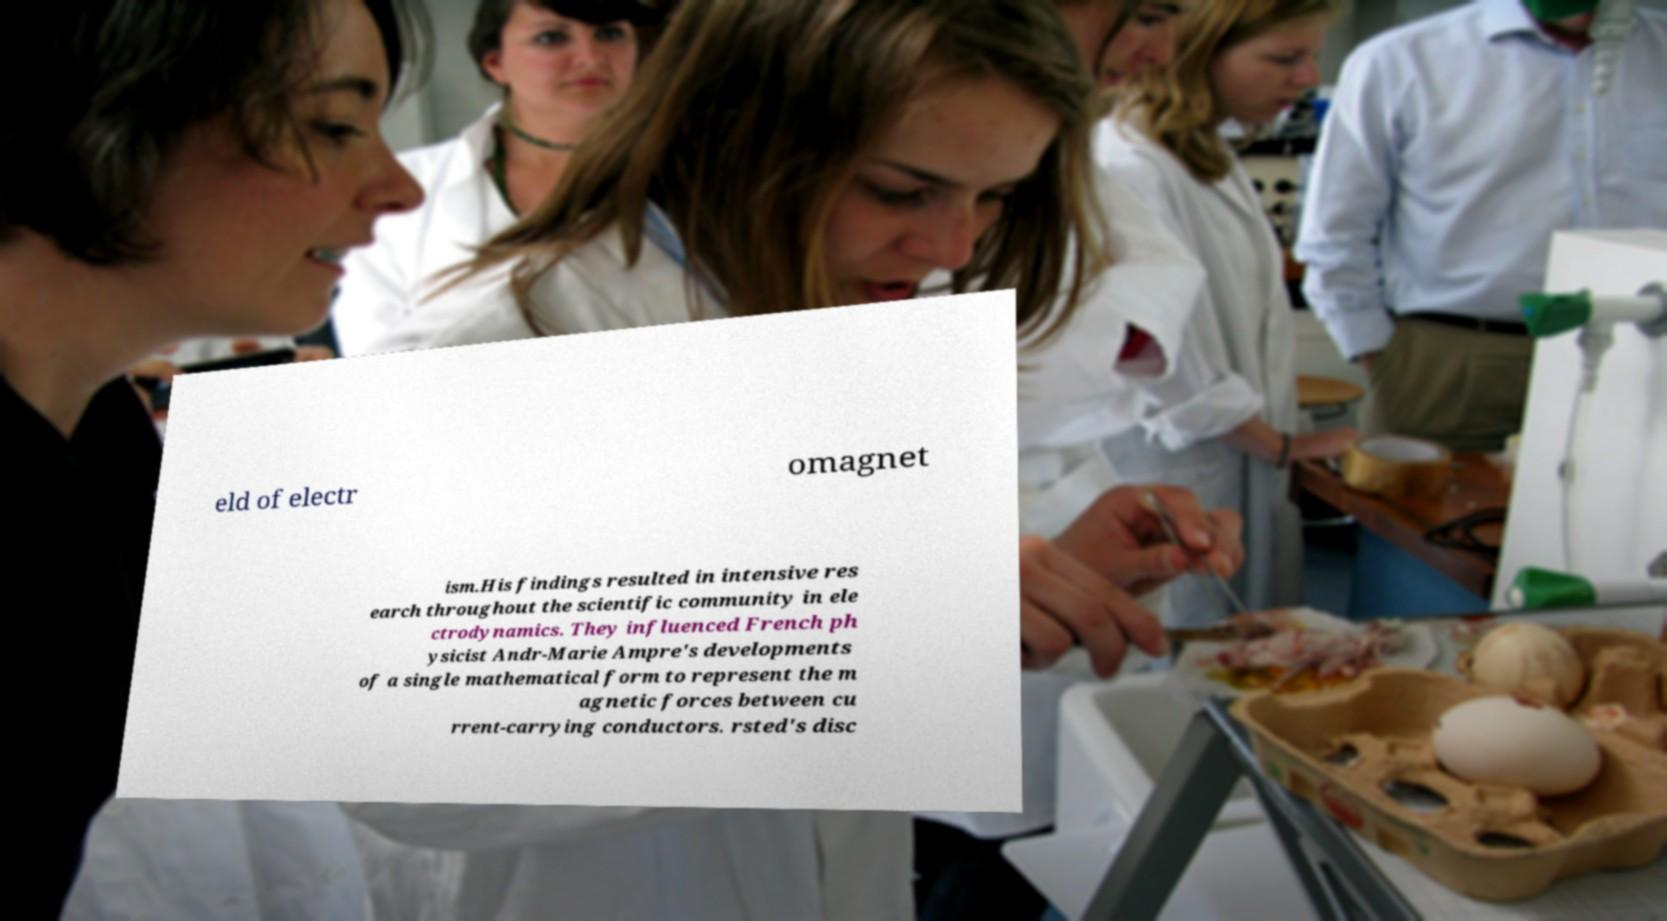Please read and relay the text visible in this image. What does it say? eld of electr omagnet ism.His findings resulted in intensive res earch throughout the scientific community in ele ctrodynamics. They influenced French ph ysicist Andr-Marie Ampre's developments of a single mathematical form to represent the m agnetic forces between cu rrent-carrying conductors. rsted's disc 